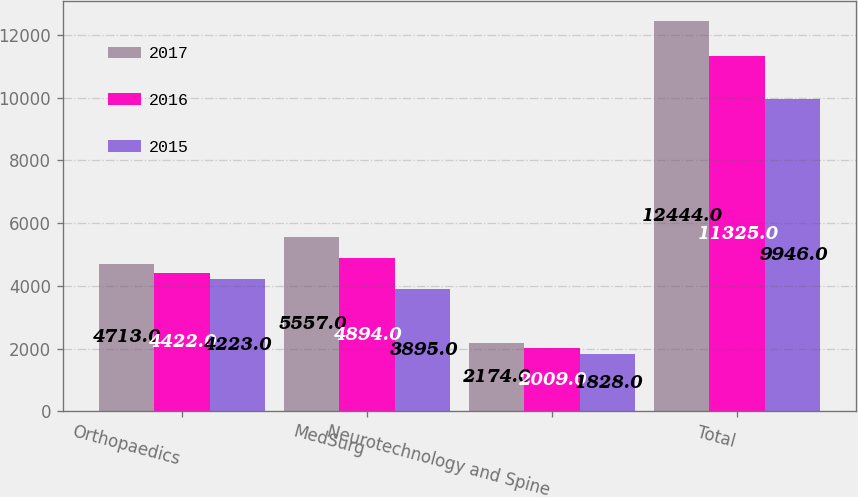Convert chart to OTSL. <chart><loc_0><loc_0><loc_500><loc_500><stacked_bar_chart><ecel><fcel>Orthopaedics<fcel>MedSurg<fcel>Neurotechnology and Spine<fcel>Total<nl><fcel>2017<fcel>4713<fcel>5557<fcel>2174<fcel>12444<nl><fcel>2016<fcel>4422<fcel>4894<fcel>2009<fcel>11325<nl><fcel>2015<fcel>4223<fcel>3895<fcel>1828<fcel>9946<nl></chart> 